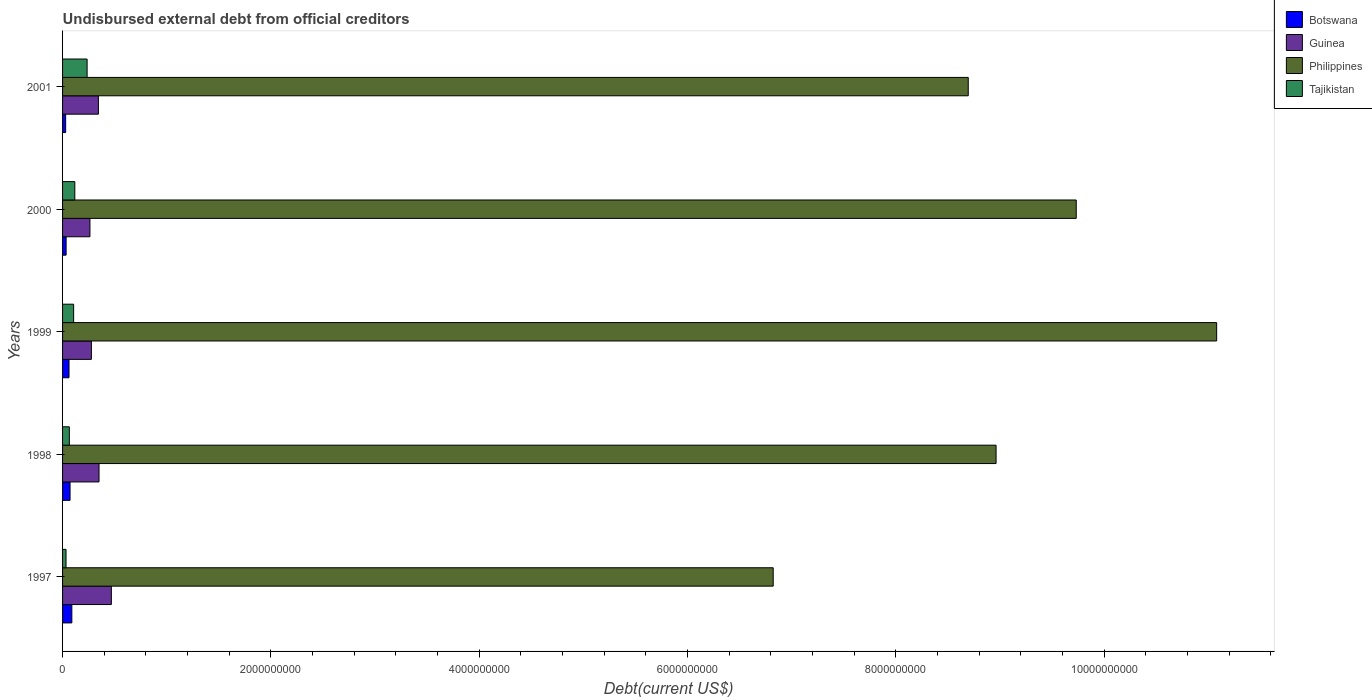Are the number of bars per tick equal to the number of legend labels?
Your response must be concise. Yes. Are the number of bars on each tick of the Y-axis equal?
Give a very brief answer. Yes. How many bars are there on the 3rd tick from the top?
Your answer should be very brief. 4. What is the label of the 2nd group of bars from the top?
Make the answer very short. 2000. In how many cases, is the number of bars for a given year not equal to the number of legend labels?
Your response must be concise. 0. What is the total debt in Philippines in 2001?
Make the answer very short. 8.70e+09. Across all years, what is the maximum total debt in Tajikistan?
Your answer should be very brief. 2.36e+08. Across all years, what is the minimum total debt in Guinea?
Give a very brief answer. 2.63e+08. In which year was the total debt in Botswana minimum?
Offer a very short reply. 2001. What is the total total debt in Philippines in the graph?
Your response must be concise. 4.53e+1. What is the difference between the total debt in Guinea in 1997 and that in 1999?
Provide a short and direct response. 1.92e+08. What is the difference between the total debt in Botswana in 2000 and the total debt in Philippines in 1999?
Make the answer very short. -1.10e+1. What is the average total debt in Botswana per year?
Offer a terse response. 5.73e+07. In the year 2000, what is the difference between the total debt in Philippines and total debt in Guinea?
Provide a short and direct response. 9.47e+09. What is the ratio of the total debt in Guinea in 1999 to that in 2001?
Keep it short and to the point. 0.8. Is the total debt in Philippines in 1997 less than that in 2001?
Make the answer very short. Yes. Is the difference between the total debt in Philippines in 1998 and 2001 greater than the difference between the total debt in Guinea in 1998 and 2001?
Make the answer very short. Yes. What is the difference between the highest and the second highest total debt in Tajikistan?
Provide a short and direct response. 1.18e+08. What is the difference between the highest and the lowest total debt in Philippines?
Give a very brief answer. 4.26e+09. In how many years, is the total debt in Tajikistan greater than the average total debt in Tajikistan taken over all years?
Your answer should be compact. 2. Is it the case that in every year, the sum of the total debt in Tajikistan and total debt in Guinea is greater than the sum of total debt in Botswana and total debt in Philippines?
Your answer should be very brief. No. What does the 4th bar from the bottom in 1997 represents?
Your answer should be very brief. Tajikistan. Is it the case that in every year, the sum of the total debt in Tajikistan and total debt in Botswana is greater than the total debt in Philippines?
Make the answer very short. No. How many bars are there?
Offer a terse response. 20. Are all the bars in the graph horizontal?
Keep it short and to the point. Yes. How many years are there in the graph?
Your response must be concise. 5. What is the difference between two consecutive major ticks on the X-axis?
Keep it short and to the point. 2.00e+09. Are the values on the major ticks of X-axis written in scientific E-notation?
Your answer should be compact. No. How many legend labels are there?
Your answer should be compact. 4. How are the legend labels stacked?
Keep it short and to the point. Vertical. What is the title of the graph?
Provide a short and direct response. Undisbursed external debt from official creditors. Does "Cyprus" appear as one of the legend labels in the graph?
Keep it short and to the point. No. What is the label or title of the X-axis?
Ensure brevity in your answer.  Debt(current US$). What is the Debt(current US$) of Botswana in 1997?
Give a very brief answer. 8.90e+07. What is the Debt(current US$) of Guinea in 1997?
Offer a very short reply. 4.68e+08. What is the Debt(current US$) of Philippines in 1997?
Offer a terse response. 6.82e+09. What is the Debt(current US$) in Tajikistan in 1997?
Make the answer very short. 3.33e+07. What is the Debt(current US$) in Botswana in 1998?
Offer a terse response. 7.19e+07. What is the Debt(current US$) in Guinea in 1998?
Your answer should be compact. 3.50e+08. What is the Debt(current US$) of Philippines in 1998?
Give a very brief answer. 8.96e+09. What is the Debt(current US$) of Tajikistan in 1998?
Offer a terse response. 6.50e+07. What is the Debt(current US$) in Botswana in 1999?
Keep it short and to the point. 6.20e+07. What is the Debt(current US$) of Guinea in 1999?
Offer a very short reply. 2.77e+08. What is the Debt(current US$) in Philippines in 1999?
Provide a succinct answer. 1.11e+1. What is the Debt(current US$) in Tajikistan in 1999?
Offer a very short reply. 1.06e+08. What is the Debt(current US$) in Botswana in 2000?
Your response must be concise. 3.40e+07. What is the Debt(current US$) of Guinea in 2000?
Your answer should be very brief. 2.63e+08. What is the Debt(current US$) in Philippines in 2000?
Provide a succinct answer. 9.73e+09. What is the Debt(current US$) in Tajikistan in 2000?
Ensure brevity in your answer.  1.18e+08. What is the Debt(current US$) of Botswana in 2001?
Your answer should be very brief. 2.97e+07. What is the Debt(current US$) of Guinea in 2001?
Provide a succinct answer. 3.44e+08. What is the Debt(current US$) in Philippines in 2001?
Give a very brief answer. 8.70e+09. What is the Debt(current US$) of Tajikistan in 2001?
Your answer should be compact. 2.36e+08. Across all years, what is the maximum Debt(current US$) in Botswana?
Keep it short and to the point. 8.90e+07. Across all years, what is the maximum Debt(current US$) of Guinea?
Your answer should be very brief. 4.68e+08. Across all years, what is the maximum Debt(current US$) of Philippines?
Give a very brief answer. 1.11e+1. Across all years, what is the maximum Debt(current US$) of Tajikistan?
Your answer should be very brief. 2.36e+08. Across all years, what is the minimum Debt(current US$) in Botswana?
Your response must be concise. 2.97e+07. Across all years, what is the minimum Debt(current US$) of Guinea?
Offer a terse response. 2.63e+08. Across all years, what is the minimum Debt(current US$) in Philippines?
Your response must be concise. 6.82e+09. Across all years, what is the minimum Debt(current US$) in Tajikistan?
Your response must be concise. 3.33e+07. What is the total Debt(current US$) in Botswana in the graph?
Your response must be concise. 2.87e+08. What is the total Debt(current US$) in Guinea in the graph?
Provide a succinct answer. 1.70e+09. What is the total Debt(current US$) in Philippines in the graph?
Offer a very short reply. 4.53e+1. What is the total Debt(current US$) in Tajikistan in the graph?
Make the answer very short. 5.58e+08. What is the difference between the Debt(current US$) in Botswana in 1997 and that in 1998?
Make the answer very short. 1.71e+07. What is the difference between the Debt(current US$) of Guinea in 1997 and that in 1998?
Offer a terse response. 1.18e+08. What is the difference between the Debt(current US$) of Philippines in 1997 and that in 1998?
Offer a very short reply. -2.14e+09. What is the difference between the Debt(current US$) of Tajikistan in 1997 and that in 1998?
Ensure brevity in your answer.  -3.17e+07. What is the difference between the Debt(current US$) in Botswana in 1997 and that in 1999?
Give a very brief answer. 2.70e+07. What is the difference between the Debt(current US$) in Guinea in 1997 and that in 1999?
Your answer should be very brief. 1.92e+08. What is the difference between the Debt(current US$) in Philippines in 1997 and that in 1999?
Offer a very short reply. -4.26e+09. What is the difference between the Debt(current US$) in Tajikistan in 1997 and that in 1999?
Provide a short and direct response. -7.30e+07. What is the difference between the Debt(current US$) of Botswana in 1997 and that in 2000?
Provide a short and direct response. 5.51e+07. What is the difference between the Debt(current US$) in Guinea in 1997 and that in 2000?
Offer a terse response. 2.06e+08. What is the difference between the Debt(current US$) in Philippines in 1997 and that in 2000?
Your response must be concise. -2.91e+09. What is the difference between the Debt(current US$) in Tajikistan in 1997 and that in 2000?
Your response must be concise. -8.44e+07. What is the difference between the Debt(current US$) of Botswana in 1997 and that in 2001?
Provide a short and direct response. 5.94e+07. What is the difference between the Debt(current US$) of Guinea in 1997 and that in 2001?
Your answer should be compact. 1.24e+08. What is the difference between the Debt(current US$) of Philippines in 1997 and that in 2001?
Offer a very short reply. -1.87e+09. What is the difference between the Debt(current US$) in Tajikistan in 1997 and that in 2001?
Provide a short and direct response. -2.02e+08. What is the difference between the Debt(current US$) of Botswana in 1998 and that in 1999?
Provide a succinct answer. 9.93e+06. What is the difference between the Debt(current US$) of Guinea in 1998 and that in 1999?
Offer a very short reply. 7.33e+07. What is the difference between the Debt(current US$) of Philippines in 1998 and that in 1999?
Provide a short and direct response. -2.12e+09. What is the difference between the Debt(current US$) of Tajikistan in 1998 and that in 1999?
Your answer should be compact. -4.13e+07. What is the difference between the Debt(current US$) of Botswana in 1998 and that in 2000?
Your answer should be very brief. 3.80e+07. What is the difference between the Debt(current US$) of Guinea in 1998 and that in 2000?
Ensure brevity in your answer.  8.73e+07. What is the difference between the Debt(current US$) of Philippines in 1998 and that in 2000?
Your response must be concise. -7.70e+08. What is the difference between the Debt(current US$) in Tajikistan in 1998 and that in 2000?
Ensure brevity in your answer.  -5.26e+07. What is the difference between the Debt(current US$) in Botswana in 1998 and that in 2001?
Offer a terse response. 4.23e+07. What is the difference between the Debt(current US$) of Guinea in 1998 and that in 2001?
Offer a terse response. 5.97e+06. What is the difference between the Debt(current US$) of Philippines in 1998 and that in 2001?
Provide a short and direct response. 2.67e+08. What is the difference between the Debt(current US$) in Tajikistan in 1998 and that in 2001?
Your answer should be compact. -1.71e+08. What is the difference between the Debt(current US$) of Botswana in 1999 and that in 2000?
Offer a terse response. 2.80e+07. What is the difference between the Debt(current US$) in Guinea in 1999 and that in 2000?
Provide a succinct answer. 1.39e+07. What is the difference between the Debt(current US$) of Philippines in 1999 and that in 2000?
Offer a terse response. 1.35e+09. What is the difference between the Debt(current US$) in Tajikistan in 1999 and that in 2000?
Offer a very short reply. -1.14e+07. What is the difference between the Debt(current US$) in Botswana in 1999 and that in 2001?
Offer a very short reply. 3.23e+07. What is the difference between the Debt(current US$) in Guinea in 1999 and that in 2001?
Your response must be concise. -6.74e+07. What is the difference between the Debt(current US$) in Philippines in 1999 and that in 2001?
Offer a very short reply. 2.39e+09. What is the difference between the Debt(current US$) in Tajikistan in 1999 and that in 2001?
Make the answer very short. -1.29e+08. What is the difference between the Debt(current US$) in Botswana in 2000 and that in 2001?
Ensure brevity in your answer.  4.32e+06. What is the difference between the Debt(current US$) in Guinea in 2000 and that in 2001?
Offer a very short reply. -8.13e+07. What is the difference between the Debt(current US$) in Philippines in 2000 and that in 2001?
Keep it short and to the point. 1.04e+09. What is the difference between the Debt(current US$) of Tajikistan in 2000 and that in 2001?
Your response must be concise. -1.18e+08. What is the difference between the Debt(current US$) of Botswana in 1997 and the Debt(current US$) of Guinea in 1998?
Your response must be concise. -2.61e+08. What is the difference between the Debt(current US$) in Botswana in 1997 and the Debt(current US$) in Philippines in 1998?
Offer a terse response. -8.87e+09. What is the difference between the Debt(current US$) in Botswana in 1997 and the Debt(current US$) in Tajikistan in 1998?
Offer a very short reply. 2.40e+07. What is the difference between the Debt(current US$) in Guinea in 1997 and the Debt(current US$) in Philippines in 1998?
Offer a very short reply. -8.49e+09. What is the difference between the Debt(current US$) of Guinea in 1997 and the Debt(current US$) of Tajikistan in 1998?
Your response must be concise. 4.03e+08. What is the difference between the Debt(current US$) of Philippines in 1997 and the Debt(current US$) of Tajikistan in 1998?
Your response must be concise. 6.76e+09. What is the difference between the Debt(current US$) in Botswana in 1997 and the Debt(current US$) in Guinea in 1999?
Make the answer very short. -1.88e+08. What is the difference between the Debt(current US$) in Botswana in 1997 and the Debt(current US$) in Philippines in 1999?
Your answer should be very brief. -1.10e+1. What is the difference between the Debt(current US$) in Botswana in 1997 and the Debt(current US$) in Tajikistan in 1999?
Offer a terse response. -1.72e+07. What is the difference between the Debt(current US$) in Guinea in 1997 and the Debt(current US$) in Philippines in 1999?
Provide a short and direct response. -1.06e+1. What is the difference between the Debt(current US$) in Guinea in 1997 and the Debt(current US$) in Tajikistan in 1999?
Offer a terse response. 3.62e+08. What is the difference between the Debt(current US$) of Philippines in 1997 and the Debt(current US$) of Tajikistan in 1999?
Provide a succinct answer. 6.72e+09. What is the difference between the Debt(current US$) of Botswana in 1997 and the Debt(current US$) of Guinea in 2000?
Keep it short and to the point. -1.74e+08. What is the difference between the Debt(current US$) in Botswana in 1997 and the Debt(current US$) in Philippines in 2000?
Ensure brevity in your answer.  -9.64e+09. What is the difference between the Debt(current US$) of Botswana in 1997 and the Debt(current US$) of Tajikistan in 2000?
Offer a very short reply. -2.86e+07. What is the difference between the Debt(current US$) in Guinea in 1997 and the Debt(current US$) in Philippines in 2000?
Offer a very short reply. -9.26e+09. What is the difference between the Debt(current US$) of Guinea in 1997 and the Debt(current US$) of Tajikistan in 2000?
Ensure brevity in your answer.  3.51e+08. What is the difference between the Debt(current US$) of Philippines in 1997 and the Debt(current US$) of Tajikistan in 2000?
Provide a succinct answer. 6.71e+09. What is the difference between the Debt(current US$) in Botswana in 1997 and the Debt(current US$) in Guinea in 2001?
Your response must be concise. -2.55e+08. What is the difference between the Debt(current US$) in Botswana in 1997 and the Debt(current US$) in Philippines in 2001?
Your response must be concise. -8.61e+09. What is the difference between the Debt(current US$) in Botswana in 1997 and the Debt(current US$) in Tajikistan in 2001?
Keep it short and to the point. -1.47e+08. What is the difference between the Debt(current US$) of Guinea in 1997 and the Debt(current US$) of Philippines in 2001?
Your answer should be compact. -8.23e+09. What is the difference between the Debt(current US$) of Guinea in 1997 and the Debt(current US$) of Tajikistan in 2001?
Offer a very short reply. 2.33e+08. What is the difference between the Debt(current US$) in Philippines in 1997 and the Debt(current US$) in Tajikistan in 2001?
Keep it short and to the point. 6.59e+09. What is the difference between the Debt(current US$) of Botswana in 1998 and the Debt(current US$) of Guinea in 1999?
Provide a succinct answer. -2.05e+08. What is the difference between the Debt(current US$) of Botswana in 1998 and the Debt(current US$) of Philippines in 1999?
Keep it short and to the point. -1.10e+1. What is the difference between the Debt(current US$) of Botswana in 1998 and the Debt(current US$) of Tajikistan in 1999?
Offer a terse response. -3.43e+07. What is the difference between the Debt(current US$) in Guinea in 1998 and the Debt(current US$) in Philippines in 1999?
Offer a very short reply. -1.07e+1. What is the difference between the Debt(current US$) in Guinea in 1998 and the Debt(current US$) in Tajikistan in 1999?
Provide a short and direct response. 2.44e+08. What is the difference between the Debt(current US$) in Philippines in 1998 and the Debt(current US$) in Tajikistan in 1999?
Keep it short and to the point. 8.86e+09. What is the difference between the Debt(current US$) in Botswana in 1998 and the Debt(current US$) in Guinea in 2000?
Your answer should be compact. -1.91e+08. What is the difference between the Debt(current US$) in Botswana in 1998 and the Debt(current US$) in Philippines in 2000?
Make the answer very short. -9.66e+09. What is the difference between the Debt(current US$) in Botswana in 1998 and the Debt(current US$) in Tajikistan in 2000?
Your response must be concise. -4.57e+07. What is the difference between the Debt(current US$) in Guinea in 1998 and the Debt(current US$) in Philippines in 2000?
Your response must be concise. -9.38e+09. What is the difference between the Debt(current US$) of Guinea in 1998 and the Debt(current US$) of Tajikistan in 2000?
Ensure brevity in your answer.  2.33e+08. What is the difference between the Debt(current US$) in Philippines in 1998 and the Debt(current US$) in Tajikistan in 2000?
Your response must be concise. 8.85e+09. What is the difference between the Debt(current US$) in Botswana in 1998 and the Debt(current US$) in Guinea in 2001?
Make the answer very short. -2.72e+08. What is the difference between the Debt(current US$) of Botswana in 1998 and the Debt(current US$) of Philippines in 2001?
Make the answer very short. -8.62e+09. What is the difference between the Debt(current US$) in Botswana in 1998 and the Debt(current US$) in Tajikistan in 2001?
Your answer should be very brief. -1.64e+08. What is the difference between the Debt(current US$) in Guinea in 1998 and the Debt(current US$) in Philippines in 2001?
Keep it short and to the point. -8.35e+09. What is the difference between the Debt(current US$) in Guinea in 1998 and the Debt(current US$) in Tajikistan in 2001?
Your answer should be very brief. 1.15e+08. What is the difference between the Debt(current US$) in Philippines in 1998 and the Debt(current US$) in Tajikistan in 2001?
Make the answer very short. 8.73e+09. What is the difference between the Debt(current US$) of Botswana in 1999 and the Debt(current US$) of Guinea in 2000?
Give a very brief answer. -2.01e+08. What is the difference between the Debt(current US$) in Botswana in 1999 and the Debt(current US$) in Philippines in 2000?
Your response must be concise. -9.67e+09. What is the difference between the Debt(current US$) of Botswana in 1999 and the Debt(current US$) of Tajikistan in 2000?
Your answer should be compact. -5.56e+07. What is the difference between the Debt(current US$) of Guinea in 1999 and the Debt(current US$) of Philippines in 2000?
Your answer should be very brief. -9.46e+09. What is the difference between the Debt(current US$) in Guinea in 1999 and the Debt(current US$) in Tajikistan in 2000?
Your answer should be compact. 1.59e+08. What is the difference between the Debt(current US$) of Philippines in 1999 and the Debt(current US$) of Tajikistan in 2000?
Ensure brevity in your answer.  1.10e+1. What is the difference between the Debt(current US$) in Botswana in 1999 and the Debt(current US$) in Guinea in 2001?
Your answer should be compact. -2.82e+08. What is the difference between the Debt(current US$) of Botswana in 1999 and the Debt(current US$) of Philippines in 2001?
Offer a very short reply. -8.63e+09. What is the difference between the Debt(current US$) in Botswana in 1999 and the Debt(current US$) in Tajikistan in 2001?
Your answer should be compact. -1.74e+08. What is the difference between the Debt(current US$) in Guinea in 1999 and the Debt(current US$) in Philippines in 2001?
Your answer should be very brief. -8.42e+09. What is the difference between the Debt(current US$) in Guinea in 1999 and the Debt(current US$) in Tajikistan in 2001?
Make the answer very short. 4.12e+07. What is the difference between the Debt(current US$) of Philippines in 1999 and the Debt(current US$) of Tajikistan in 2001?
Your answer should be very brief. 1.08e+1. What is the difference between the Debt(current US$) of Botswana in 2000 and the Debt(current US$) of Guinea in 2001?
Your answer should be compact. -3.10e+08. What is the difference between the Debt(current US$) of Botswana in 2000 and the Debt(current US$) of Philippines in 2001?
Your answer should be very brief. -8.66e+09. What is the difference between the Debt(current US$) in Botswana in 2000 and the Debt(current US$) in Tajikistan in 2001?
Make the answer very short. -2.02e+08. What is the difference between the Debt(current US$) of Guinea in 2000 and the Debt(current US$) of Philippines in 2001?
Your answer should be very brief. -8.43e+09. What is the difference between the Debt(current US$) of Guinea in 2000 and the Debt(current US$) of Tajikistan in 2001?
Provide a succinct answer. 2.73e+07. What is the difference between the Debt(current US$) in Philippines in 2000 and the Debt(current US$) in Tajikistan in 2001?
Ensure brevity in your answer.  9.50e+09. What is the average Debt(current US$) in Botswana per year?
Your answer should be compact. 5.73e+07. What is the average Debt(current US$) in Guinea per year?
Ensure brevity in your answer.  3.40e+08. What is the average Debt(current US$) of Philippines per year?
Give a very brief answer. 9.06e+09. What is the average Debt(current US$) in Tajikistan per year?
Offer a very short reply. 1.12e+08. In the year 1997, what is the difference between the Debt(current US$) in Botswana and Debt(current US$) in Guinea?
Provide a short and direct response. -3.79e+08. In the year 1997, what is the difference between the Debt(current US$) in Botswana and Debt(current US$) in Philippines?
Offer a terse response. -6.73e+09. In the year 1997, what is the difference between the Debt(current US$) of Botswana and Debt(current US$) of Tajikistan?
Give a very brief answer. 5.58e+07. In the year 1997, what is the difference between the Debt(current US$) in Guinea and Debt(current US$) in Philippines?
Ensure brevity in your answer.  -6.35e+09. In the year 1997, what is the difference between the Debt(current US$) of Guinea and Debt(current US$) of Tajikistan?
Provide a short and direct response. 4.35e+08. In the year 1997, what is the difference between the Debt(current US$) in Philippines and Debt(current US$) in Tajikistan?
Give a very brief answer. 6.79e+09. In the year 1998, what is the difference between the Debt(current US$) of Botswana and Debt(current US$) of Guinea?
Your answer should be compact. -2.78e+08. In the year 1998, what is the difference between the Debt(current US$) of Botswana and Debt(current US$) of Philippines?
Keep it short and to the point. -8.89e+09. In the year 1998, what is the difference between the Debt(current US$) of Botswana and Debt(current US$) of Tajikistan?
Ensure brevity in your answer.  6.95e+06. In the year 1998, what is the difference between the Debt(current US$) in Guinea and Debt(current US$) in Philippines?
Provide a short and direct response. -8.61e+09. In the year 1998, what is the difference between the Debt(current US$) in Guinea and Debt(current US$) in Tajikistan?
Keep it short and to the point. 2.85e+08. In the year 1998, what is the difference between the Debt(current US$) in Philippines and Debt(current US$) in Tajikistan?
Offer a terse response. 8.90e+09. In the year 1999, what is the difference between the Debt(current US$) in Botswana and Debt(current US$) in Guinea?
Provide a short and direct response. -2.15e+08. In the year 1999, what is the difference between the Debt(current US$) of Botswana and Debt(current US$) of Philippines?
Your answer should be very brief. -1.10e+1. In the year 1999, what is the difference between the Debt(current US$) in Botswana and Debt(current US$) in Tajikistan?
Provide a succinct answer. -4.43e+07. In the year 1999, what is the difference between the Debt(current US$) of Guinea and Debt(current US$) of Philippines?
Your answer should be compact. -1.08e+1. In the year 1999, what is the difference between the Debt(current US$) in Guinea and Debt(current US$) in Tajikistan?
Your response must be concise. 1.71e+08. In the year 1999, what is the difference between the Debt(current US$) in Philippines and Debt(current US$) in Tajikistan?
Give a very brief answer. 1.10e+1. In the year 2000, what is the difference between the Debt(current US$) in Botswana and Debt(current US$) in Guinea?
Make the answer very short. -2.29e+08. In the year 2000, what is the difference between the Debt(current US$) of Botswana and Debt(current US$) of Philippines?
Provide a short and direct response. -9.70e+09. In the year 2000, what is the difference between the Debt(current US$) in Botswana and Debt(current US$) in Tajikistan?
Your answer should be compact. -8.36e+07. In the year 2000, what is the difference between the Debt(current US$) of Guinea and Debt(current US$) of Philippines?
Ensure brevity in your answer.  -9.47e+09. In the year 2000, what is the difference between the Debt(current US$) in Guinea and Debt(current US$) in Tajikistan?
Provide a succinct answer. 1.45e+08. In the year 2000, what is the difference between the Debt(current US$) in Philippines and Debt(current US$) in Tajikistan?
Ensure brevity in your answer.  9.62e+09. In the year 2001, what is the difference between the Debt(current US$) in Botswana and Debt(current US$) in Guinea?
Offer a terse response. -3.15e+08. In the year 2001, what is the difference between the Debt(current US$) of Botswana and Debt(current US$) of Philippines?
Ensure brevity in your answer.  -8.67e+09. In the year 2001, what is the difference between the Debt(current US$) in Botswana and Debt(current US$) in Tajikistan?
Ensure brevity in your answer.  -2.06e+08. In the year 2001, what is the difference between the Debt(current US$) in Guinea and Debt(current US$) in Philippines?
Your answer should be very brief. -8.35e+09. In the year 2001, what is the difference between the Debt(current US$) in Guinea and Debt(current US$) in Tajikistan?
Provide a short and direct response. 1.09e+08. In the year 2001, what is the difference between the Debt(current US$) of Philippines and Debt(current US$) of Tajikistan?
Make the answer very short. 8.46e+09. What is the ratio of the Debt(current US$) of Botswana in 1997 to that in 1998?
Offer a very short reply. 1.24. What is the ratio of the Debt(current US$) of Guinea in 1997 to that in 1998?
Provide a succinct answer. 1.34. What is the ratio of the Debt(current US$) in Philippines in 1997 to that in 1998?
Ensure brevity in your answer.  0.76. What is the ratio of the Debt(current US$) in Tajikistan in 1997 to that in 1998?
Offer a very short reply. 0.51. What is the ratio of the Debt(current US$) of Botswana in 1997 to that in 1999?
Offer a terse response. 1.44. What is the ratio of the Debt(current US$) of Guinea in 1997 to that in 1999?
Your response must be concise. 1.69. What is the ratio of the Debt(current US$) in Philippines in 1997 to that in 1999?
Make the answer very short. 0.62. What is the ratio of the Debt(current US$) in Tajikistan in 1997 to that in 1999?
Your answer should be compact. 0.31. What is the ratio of the Debt(current US$) of Botswana in 1997 to that in 2000?
Make the answer very short. 2.62. What is the ratio of the Debt(current US$) in Guinea in 1997 to that in 2000?
Offer a very short reply. 1.78. What is the ratio of the Debt(current US$) in Philippines in 1997 to that in 2000?
Make the answer very short. 0.7. What is the ratio of the Debt(current US$) in Tajikistan in 1997 to that in 2000?
Keep it short and to the point. 0.28. What is the ratio of the Debt(current US$) of Botswana in 1997 to that in 2001?
Your answer should be compact. 3. What is the ratio of the Debt(current US$) in Guinea in 1997 to that in 2001?
Make the answer very short. 1.36. What is the ratio of the Debt(current US$) in Philippines in 1997 to that in 2001?
Offer a very short reply. 0.78. What is the ratio of the Debt(current US$) of Tajikistan in 1997 to that in 2001?
Offer a terse response. 0.14. What is the ratio of the Debt(current US$) in Botswana in 1998 to that in 1999?
Ensure brevity in your answer.  1.16. What is the ratio of the Debt(current US$) in Guinea in 1998 to that in 1999?
Provide a succinct answer. 1.26. What is the ratio of the Debt(current US$) in Philippines in 1998 to that in 1999?
Offer a very short reply. 0.81. What is the ratio of the Debt(current US$) of Tajikistan in 1998 to that in 1999?
Your response must be concise. 0.61. What is the ratio of the Debt(current US$) in Botswana in 1998 to that in 2000?
Provide a succinct answer. 2.12. What is the ratio of the Debt(current US$) of Guinea in 1998 to that in 2000?
Ensure brevity in your answer.  1.33. What is the ratio of the Debt(current US$) of Philippines in 1998 to that in 2000?
Offer a very short reply. 0.92. What is the ratio of the Debt(current US$) of Tajikistan in 1998 to that in 2000?
Offer a very short reply. 0.55. What is the ratio of the Debt(current US$) in Botswana in 1998 to that in 2001?
Your answer should be compact. 2.43. What is the ratio of the Debt(current US$) of Guinea in 1998 to that in 2001?
Ensure brevity in your answer.  1.02. What is the ratio of the Debt(current US$) in Philippines in 1998 to that in 2001?
Give a very brief answer. 1.03. What is the ratio of the Debt(current US$) in Tajikistan in 1998 to that in 2001?
Your answer should be compact. 0.28. What is the ratio of the Debt(current US$) in Botswana in 1999 to that in 2000?
Keep it short and to the point. 1.82. What is the ratio of the Debt(current US$) of Guinea in 1999 to that in 2000?
Ensure brevity in your answer.  1.05. What is the ratio of the Debt(current US$) in Philippines in 1999 to that in 2000?
Your answer should be compact. 1.14. What is the ratio of the Debt(current US$) in Tajikistan in 1999 to that in 2000?
Your response must be concise. 0.9. What is the ratio of the Debt(current US$) of Botswana in 1999 to that in 2001?
Your answer should be very brief. 2.09. What is the ratio of the Debt(current US$) in Guinea in 1999 to that in 2001?
Your answer should be very brief. 0.8. What is the ratio of the Debt(current US$) of Philippines in 1999 to that in 2001?
Give a very brief answer. 1.27. What is the ratio of the Debt(current US$) of Tajikistan in 1999 to that in 2001?
Give a very brief answer. 0.45. What is the ratio of the Debt(current US$) of Botswana in 2000 to that in 2001?
Provide a short and direct response. 1.15. What is the ratio of the Debt(current US$) in Guinea in 2000 to that in 2001?
Your answer should be compact. 0.76. What is the ratio of the Debt(current US$) of Philippines in 2000 to that in 2001?
Offer a terse response. 1.12. What is the ratio of the Debt(current US$) in Tajikistan in 2000 to that in 2001?
Give a very brief answer. 0.5. What is the difference between the highest and the second highest Debt(current US$) in Botswana?
Provide a succinct answer. 1.71e+07. What is the difference between the highest and the second highest Debt(current US$) of Guinea?
Provide a short and direct response. 1.18e+08. What is the difference between the highest and the second highest Debt(current US$) of Philippines?
Give a very brief answer. 1.35e+09. What is the difference between the highest and the second highest Debt(current US$) of Tajikistan?
Your answer should be compact. 1.18e+08. What is the difference between the highest and the lowest Debt(current US$) of Botswana?
Offer a very short reply. 5.94e+07. What is the difference between the highest and the lowest Debt(current US$) of Guinea?
Give a very brief answer. 2.06e+08. What is the difference between the highest and the lowest Debt(current US$) of Philippines?
Provide a short and direct response. 4.26e+09. What is the difference between the highest and the lowest Debt(current US$) in Tajikistan?
Ensure brevity in your answer.  2.02e+08. 